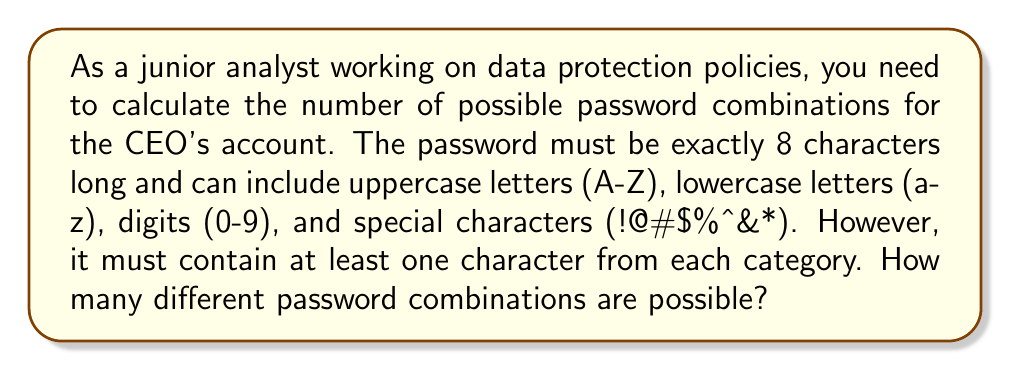Can you solve this math problem? Let's approach this step-by-step:

1) First, we need to calculate the total number of characters available:
   - 26 uppercase letters
   - 26 lowercase letters
   - 10 digits
   - 8 special characters
   Total: $26 + 26 + 10 + 8 = 70$ characters

2) If there were no restrictions, the total number of 8-character passwords would be $70^8$.

3) However, we need to subtract the passwords that don't meet the criteria of having at least one character from each category. We can use the Inclusion-Exclusion Principle for this.

4) Let's define:
   $A$ = passwords missing uppercase letters
   $B$ = passwords missing lowercase letters
   $C$ = passwords missing digits
   $D$ = passwords missing special characters

5) We need to calculate $|A \cup B \cup C \cup D|$ and subtract it from $70^8$.

6) Using the Inclusion-Exclusion Principle:

   $|A \cup B \cup C \cup D| = |A| + |B| + |C| + |D| - |A \cap B| - |A \cap C| - |A \cap D| - |B \cap C| - |B \cap D| - |C \cap D| + |A \cap B \cap C| + |A \cap B \cap D| + |A \cap C \cap D| + |B \cap C \cap D| - |A \cap B \cap C \cap D|$

7) Calculating each term:
   $|A| = 44^8$ (passwords using only lowercase, digits, and special chars)
   $|B| = 44^8$
   $|C| = 60^8$
   $|D| = 62^8$

   $|A \cap B| = 18^8$ (passwords using only digits and special chars)
   $|A \cap C| = 34^8$
   $|A \cap D| = 36^8$
   $|B \cap C| = 34^8$
   $|B \cap D| = 36^8$
   $|C \cap D| = 52^8$

   $|A \cap B \cap C| = 8^8$ (passwords using only special chars)
   $|A \cap B \cap D| = 10^8$
   $|A \cap C \cap D| = 26^8$
   $|B \cap C \cap D| = 26^8$

   $|A \cap B \cap C \cap D| = 0^8 = 0$ (no passwords missing all categories)

8) Substituting these values into the Inclusion-Exclusion formula:

   $|A \cup B \cup C \cup D| = 2 \cdot 44^8 + 60^8 + 62^8 - 2 \cdot 18^8 - 4 \cdot 34^8 - 4 \cdot 36^8 - 52^8 + 8^8 + 3 \cdot 10^8 + 2 \cdot 26^8 - 0$

9) The final number of valid passwords is:

   $70^8 - |A \cup B \cup C \cup D|$
Answer: $$70^8 - (2 \cdot 44^8 + 60^8 + 62^8 - 2 \cdot 18^8 - 4 \cdot 34^8 - 4 \cdot 36^8 - 52^8 + 8^8 + 3 \cdot 10^8 + 2 \cdot 26^8)$$ 